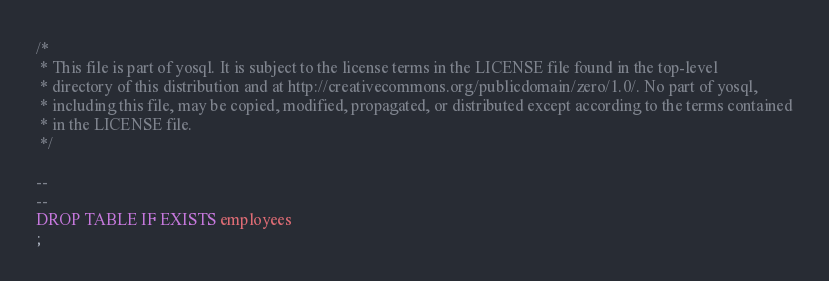<code> <loc_0><loc_0><loc_500><loc_500><_SQL_>/*
 * This file is part of yosql. It is subject to the license terms in the LICENSE file found in the top-level
 * directory of this distribution and at http://creativecommons.org/publicdomain/zero/1.0/. No part of yosql,
 * including this file, may be copied, modified, propagated, or distributed except according to the terms contained
 * in the LICENSE file.
 */

--
--
DROP TABLE IF EXISTS employees
;
</code> 